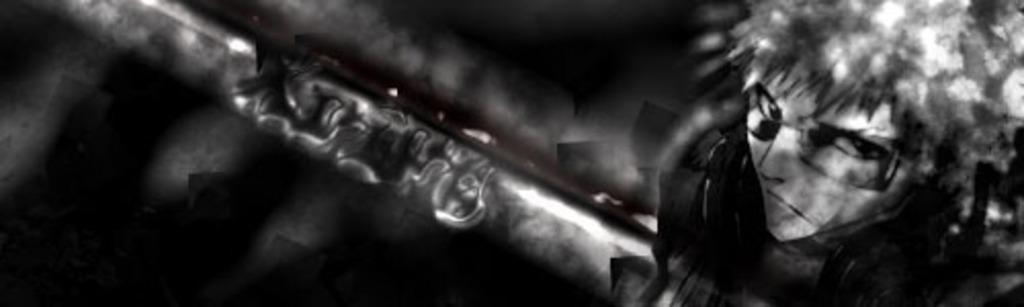Can you describe this image briefly? In this image I can see the digital art of a person holding a object in his hand and the dark background. 